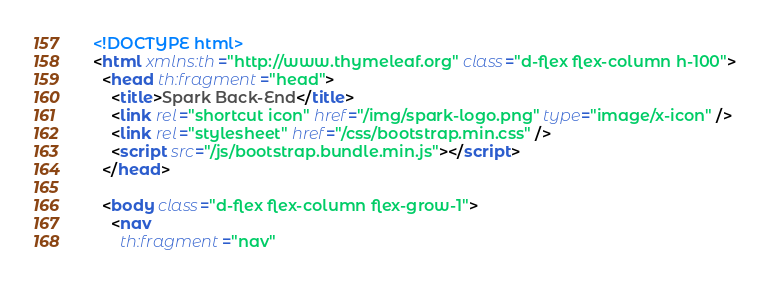<code> <loc_0><loc_0><loc_500><loc_500><_HTML_><!DOCTYPE html>
<html xmlns:th="http://www.thymeleaf.org" class="d-flex flex-column h-100">
  <head th:fragment="head">
    <title>Spark Back-End</title>
    <link rel="shortcut icon" href="/img/spark-logo.png" type="image/x-icon" />
    <link rel="stylesheet" href="/css/bootstrap.min.css" />
    <script src="/js/bootstrap.bundle.min.js"></script>
  </head>

  <body class="d-flex flex-column flex-grow-1">
    <nav
      th:fragment="nav"</code> 